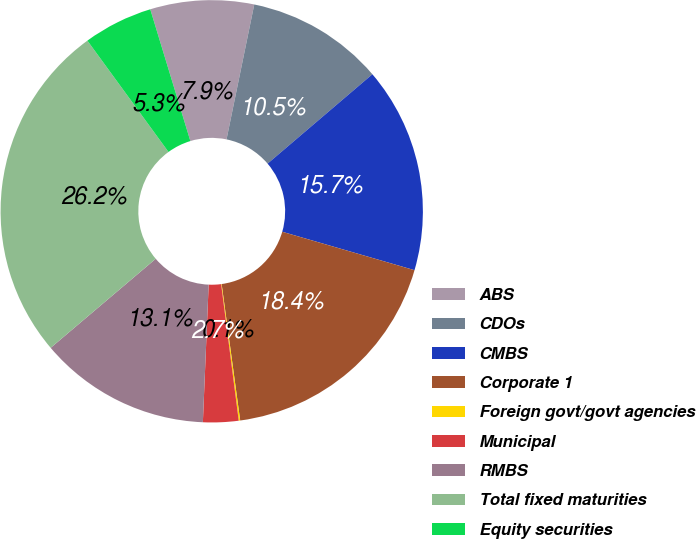<chart> <loc_0><loc_0><loc_500><loc_500><pie_chart><fcel>ABS<fcel>CDOs<fcel>CMBS<fcel>Corporate 1<fcel>Foreign govt/govt agencies<fcel>Municipal<fcel>RMBS<fcel>Total fixed maturities<fcel>Equity securities<nl><fcel>7.93%<fcel>10.53%<fcel>15.74%<fcel>18.35%<fcel>0.11%<fcel>2.71%<fcel>13.14%<fcel>26.17%<fcel>5.32%<nl></chart> 